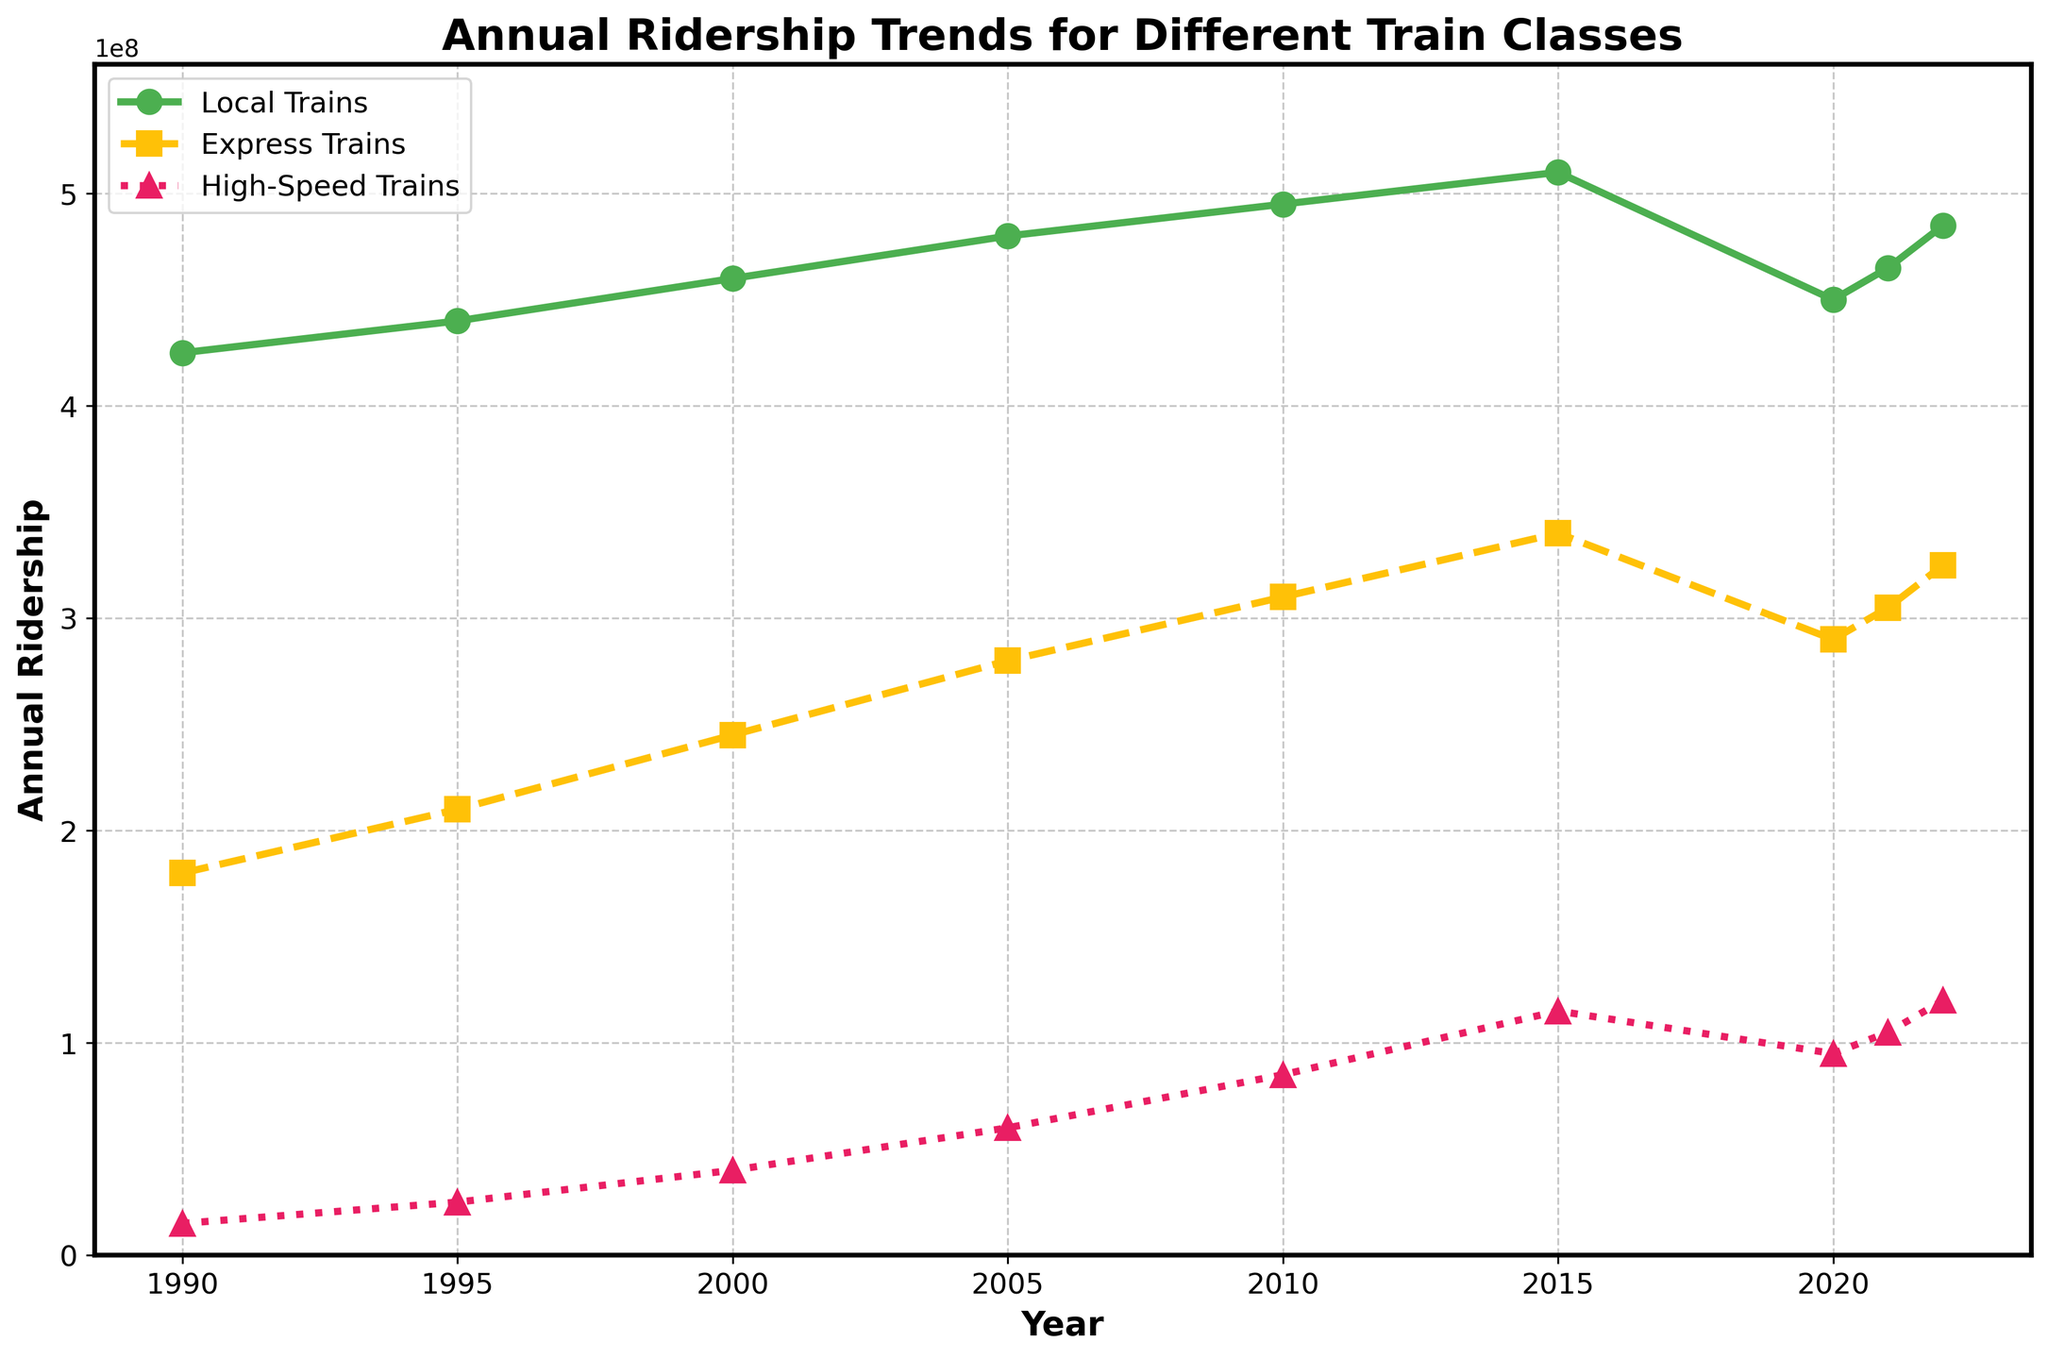What's the overall ridership trend for High-Speed Trains? Observing the line for High-Speed Trains, we see an upward trend in riders from 1990 to 2022, with some fluctuations. Starting from 15 million riders in 1990 to 120 million in 2022.
Answer: Upward trend Which year had the highest ridership for Local Trains? From the figure, the peak ridership for Local Trains occurs around 2015, with 510 million riders.
Answer: 2015 What was the change in ridership for Express Trains from 2000 to 2010? In 2000, Express Trains had 245 million riders, whereas, in 2010, they had 310 million. The change is 310 million - 245 million = 65 million.
Answer: 65 million Compare the ridership for Local Trains and High-Speed Trains in 2020. In 2020, Local Trains had 450 million riders, and High-Speed Trains had 95 million. Local Trains had more riders.
Answer: Local Trains had more riders Which train class showed the most consistent growth pattern over the years? By observing the lines, Local Trains show a steady and consistent increase, while Express and High-Speed Trains have fluctuations with sharper rises and dips.
Answer: Local Trains What was the combined ridership for all train classes in 2005? Local Trains had 480 million, Express Trains had 280 million, and High-Speed Trains had 60 million in 2005. The combined ridership is 480 million + 280 million + 60 million = 820 million.
Answer: 820 million In which year did High-Speed Trains' ridership reach 100 million for the first time? By observing the line for High-Speed Trains, the ridership crosses 100 million in 2021, reaching 105 million.
Answer: 2021 What's the average annual ridership of Express Trains between 1990 and 2022? Adding the ridership from 1990 to 2022 for Express Trains: 180 + 210 + 245 + 280 + 310 + 340 + 290 + 305 + 325 = 2485 million. Dividing by the number of years (9), the average is 2485 / 9 ≈ 276.11 million.
Answer: 276.11 million Which train class experienced a significant drop in ridership between 2015 and 2020? Observing the lines, Local Trains had a noticeable drop from 510 million in 2015 to 450 million in 2020.
Answer: Local Trains What is the trend difference between Express Trains and High-Speed Trains over the years? Express Trains show an upward trend but with some slowing down after 2015, whereas High-Speed Trains show a strong upward trend without slowing down significantly. High-Speed Trains' overall growth rate appears steeper.
Answer: High-Speed Trains have a steeper upward trend 